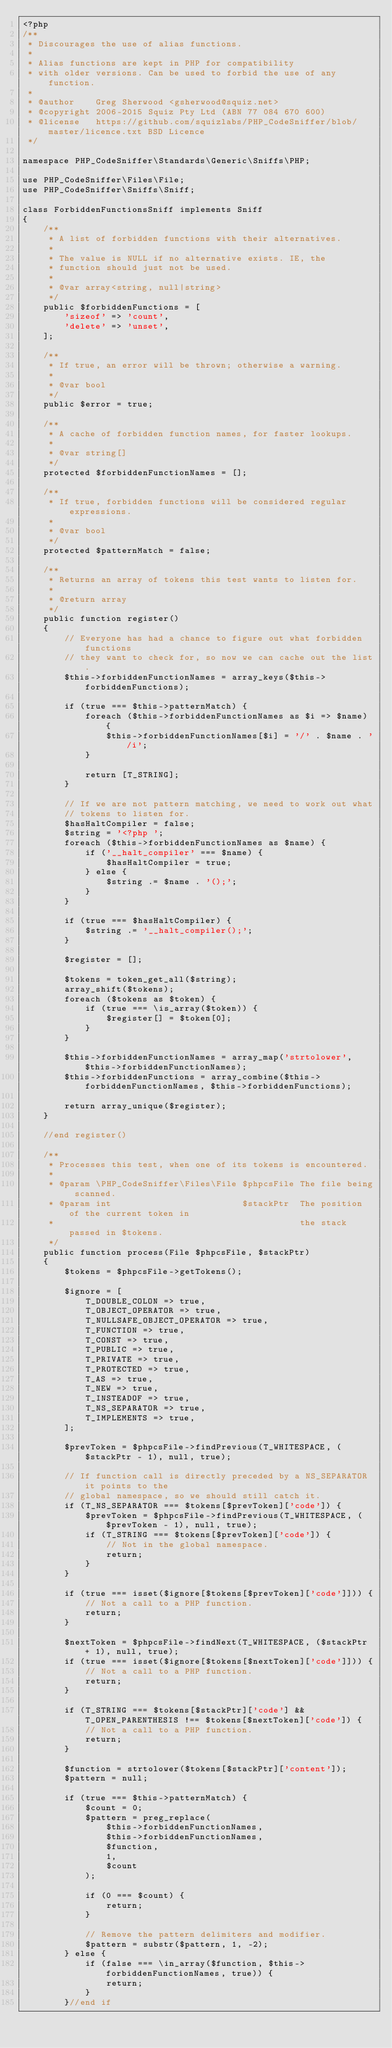Convert code to text. <code><loc_0><loc_0><loc_500><loc_500><_PHP_><?php
/**
 * Discourages the use of alias functions.
 *
 * Alias functions are kept in PHP for compatibility
 * with older versions. Can be used to forbid the use of any function.
 *
 * @author    Greg Sherwood <gsherwood@squiz.net>
 * @copyright 2006-2015 Squiz Pty Ltd (ABN 77 084 670 600)
 * @license   https://github.com/squizlabs/PHP_CodeSniffer/blob/master/licence.txt BSD Licence
 */

namespace PHP_CodeSniffer\Standards\Generic\Sniffs\PHP;

use PHP_CodeSniffer\Files\File;
use PHP_CodeSniffer\Sniffs\Sniff;

class ForbiddenFunctionsSniff implements Sniff
{
    /**
     * A list of forbidden functions with their alternatives.
     *
     * The value is NULL if no alternative exists. IE, the
     * function should just not be used.
     *
     * @var array<string, null|string>
     */
    public $forbiddenFunctions = [
        'sizeof' => 'count',
        'delete' => 'unset',
    ];

    /**
     * If true, an error will be thrown; otherwise a warning.
     *
     * @var bool
     */
    public $error = true;

    /**
     * A cache of forbidden function names, for faster lookups.
     *
     * @var string[]
     */
    protected $forbiddenFunctionNames = [];

    /**
     * If true, forbidden functions will be considered regular expressions.
     *
     * @var bool
     */
    protected $patternMatch = false;

    /**
     * Returns an array of tokens this test wants to listen for.
     *
     * @return array
     */
    public function register()
    {
        // Everyone has had a chance to figure out what forbidden functions
        // they want to check for, so now we can cache out the list.
        $this->forbiddenFunctionNames = array_keys($this->forbiddenFunctions);

        if (true === $this->patternMatch) {
            foreach ($this->forbiddenFunctionNames as $i => $name) {
                $this->forbiddenFunctionNames[$i] = '/' . $name . '/i';
            }

            return [T_STRING];
        }

        // If we are not pattern matching, we need to work out what
        // tokens to listen for.
        $hasHaltCompiler = false;
        $string = '<?php ';
        foreach ($this->forbiddenFunctionNames as $name) {
            if ('__halt_compiler' === $name) {
                $hasHaltCompiler = true;
            } else {
                $string .= $name . '();';
            }
        }

        if (true === $hasHaltCompiler) {
            $string .= '__halt_compiler();';
        }

        $register = [];

        $tokens = token_get_all($string);
        array_shift($tokens);
        foreach ($tokens as $token) {
            if (true === \is_array($token)) {
                $register[] = $token[0];
            }
        }

        $this->forbiddenFunctionNames = array_map('strtolower', $this->forbiddenFunctionNames);
        $this->forbiddenFunctions = array_combine($this->forbiddenFunctionNames, $this->forbiddenFunctions);

        return array_unique($register);
    }

    //end register()

    /**
     * Processes this test, when one of its tokens is encountered.
     *
     * @param \PHP_CodeSniffer\Files\File $phpcsFile The file being scanned.
     * @param int                         $stackPtr  The position of the current token in
     *                                               the stack passed in $tokens.
     */
    public function process(File $phpcsFile, $stackPtr)
    {
        $tokens = $phpcsFile->getTokens();

        $ignore = [
            T_DOUBLE_COLON => true,
            T_OBJECT_OPERATOR => true,
            T_NULLSAFE_OBJECT_OPERATOR => true,
            T_FUNCTION => true,
            T_CONST => true,
            T_PUBLIC => true,
            T_PRIVATE => true,
            T_PROTECTED => true,
            T_AS => true,
            T_NEW => true,
            T_INSTEADOF => true,
            T_NS_SEPARATOR => true,
            T_IMPLEMENTS => true,
        ];

        $prevToken = $phpcsFile->findPrevious(T_WHITESPACE, ($stackPtr - 1), null, true);

        // If function call is directly preceded by a NS_SEPARATOR it points to the
        // global namespace, so we should still catch it.
        if (T_NS_SEPARATOR === $tokens[$prevToken]['code']) {
            $prevToken = $phpcsFile->findPrevious(T_WHITESPACE, ($prevToken - 1), null, true);
            if (T_STRING === $tokens[$prevToken]['code']) {
                // Not in the global namespace.
                return;
            }
        }

        if (true === isset($ignore[$tokens[$prevToken]['code']])) {
            // Not a call to a PHP function.
            return;
        }

        $nextToken = $phpcsFile->findNext(T_WHITESPACE, ($stackPtr + 1), null, true);
        if (true === isset($ignore[$tokens[$nextToken]['code']])) {
            // Not a call to a PHP function.
            return;
        }

        if (T_STRING === $tokens[$stackPtr]['code'] && T_OPEN_PARENTHESIS !== $tokens[$nextToken]['code']) {
            // Not a call to a PHP function.
            return;
        }

        $function = strtolower($tokens[$stackPtr]['content']);
        $pattern = null;

        if (true === $this->patternMatch) {
            $count = 0;
            $pattern = preg_replace(
                $this->forbiddenFunctionNames,
                $this->forbiddenFunctionNames,
                $function,
                1,
                $count
            );

            if (0 === $count) {
                return;
            }

            // Remove the pattern delimiters and modifier.
            $pattern = substr($pattern, 1, -2);
        } else {
            if (false === \in_array($function, $this->forbiddenFunctionNames, true)) {
                return;
            }
        }//end if
</code> 